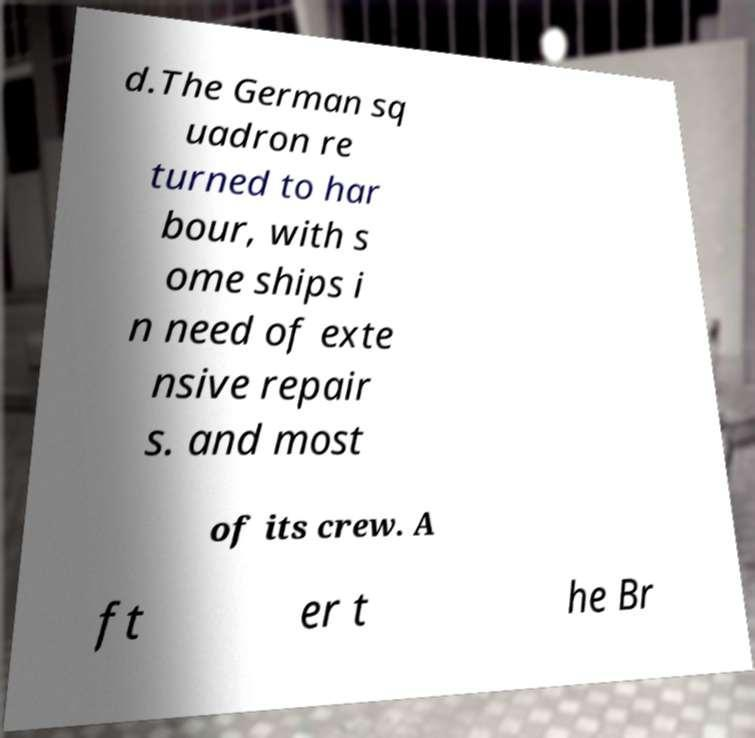Please read and relay the text visible in this image. What does it say? d.The German sq uadron re turned to har bour, with s ome ships i n need of exte nsive repair s. and most of its crew. A ft er t he Br 